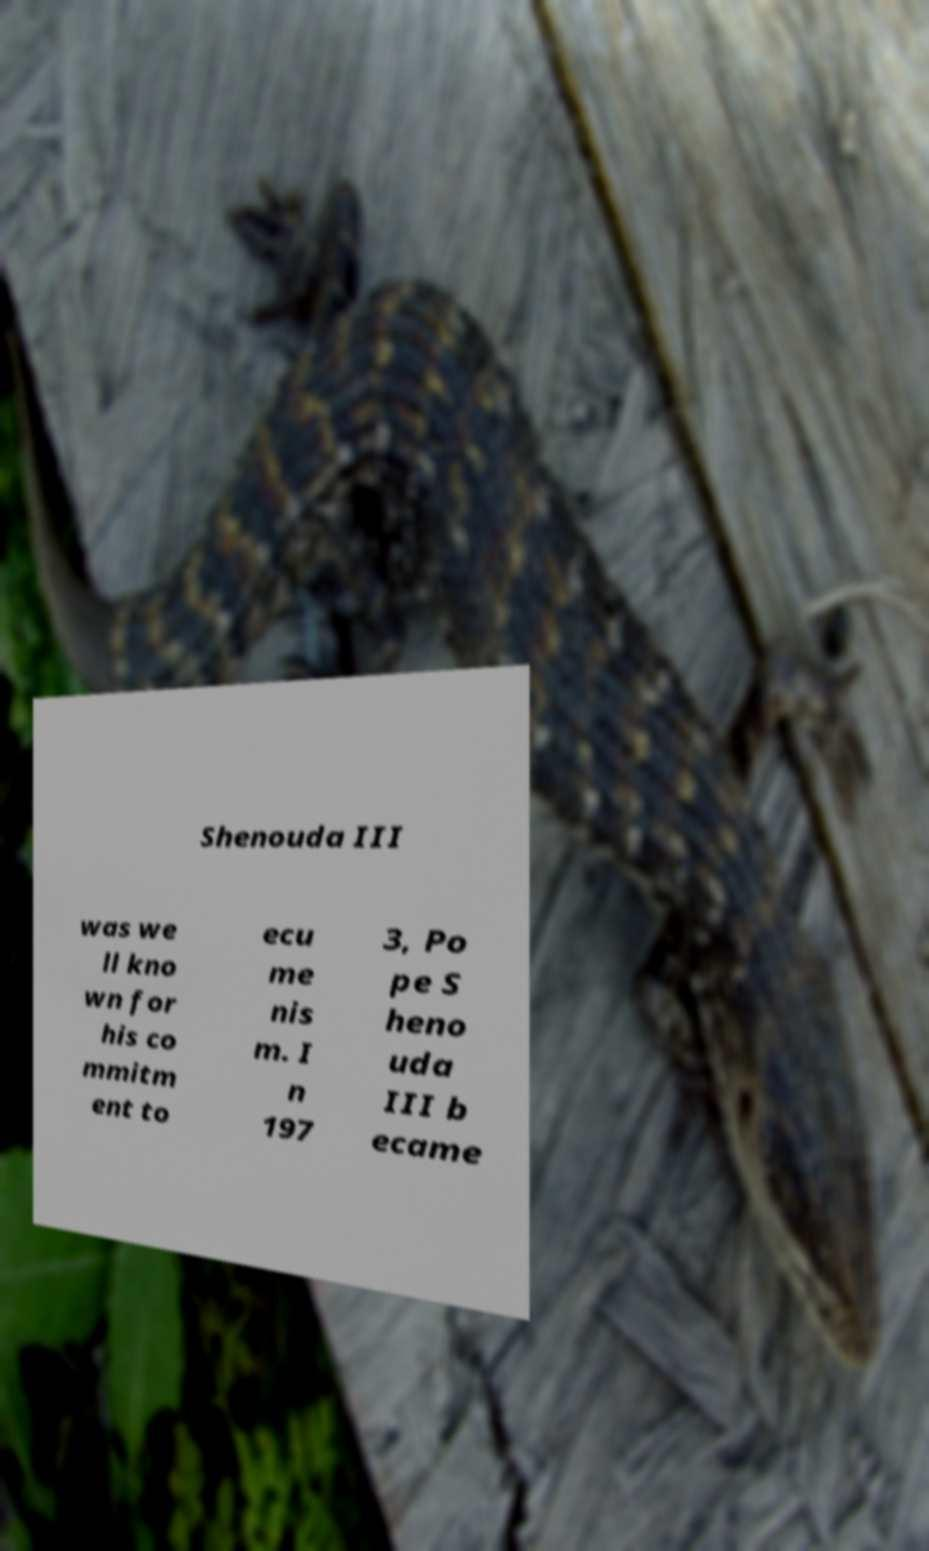Please identify and transcribe the text found in this image. Shenouda III was we ll kno wn for his co mmitm ent to ecu me nis m. I n 197 3, Po pe S heno uda III b ecame 